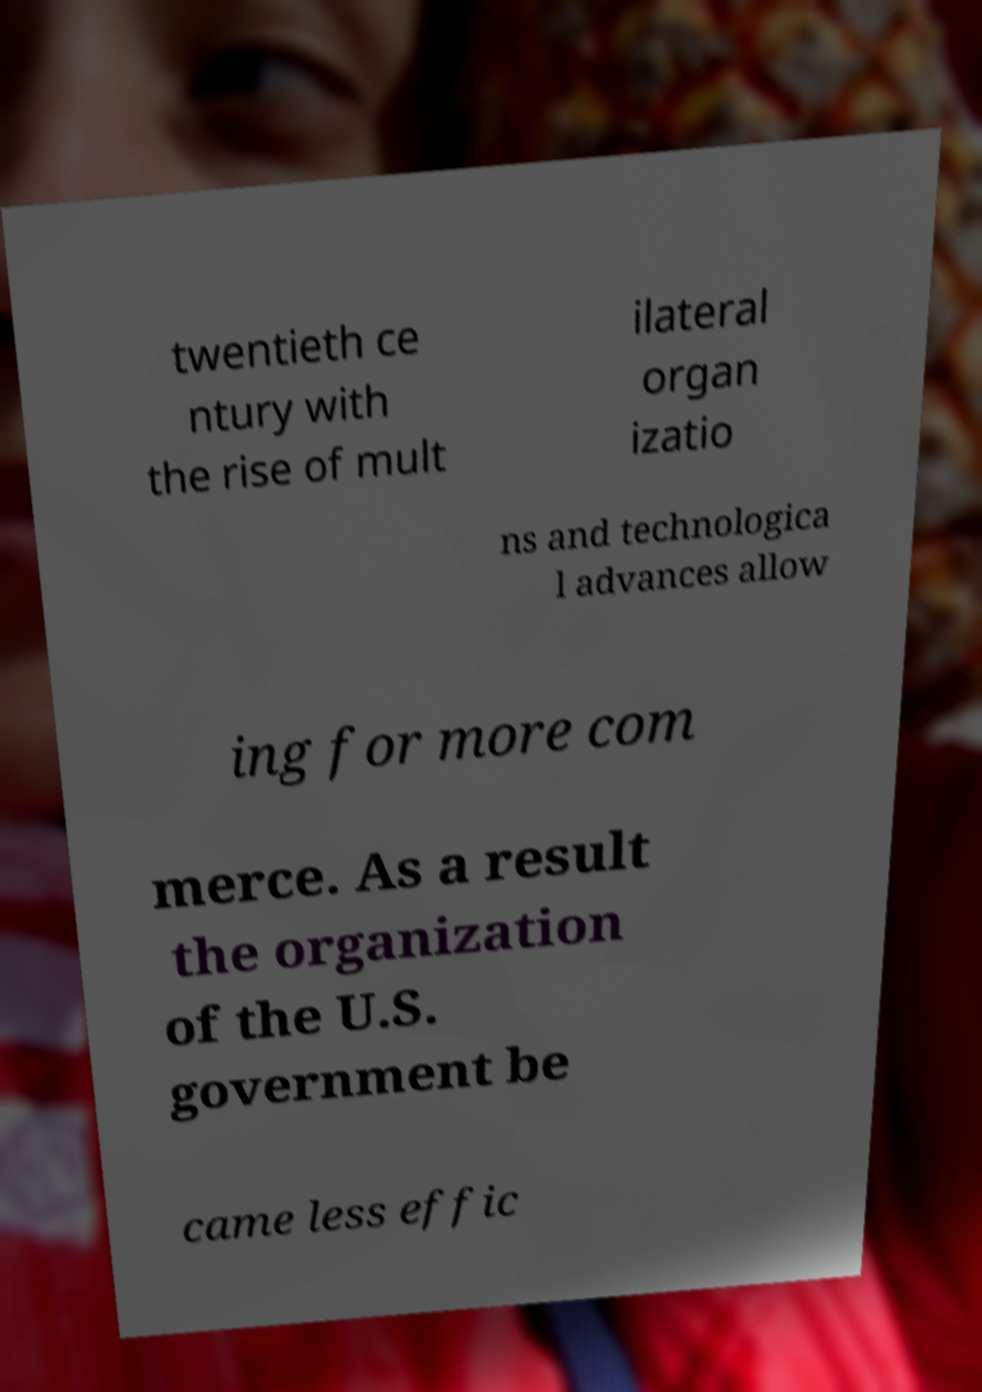Can you accurately transcribe the text from the provided image for me? twentieth ce ntury with the rise of mult ilateral organ izatio ns and technologica l advances allow ing for more com merce. As a result the organization of the U.S. government be came less effic 